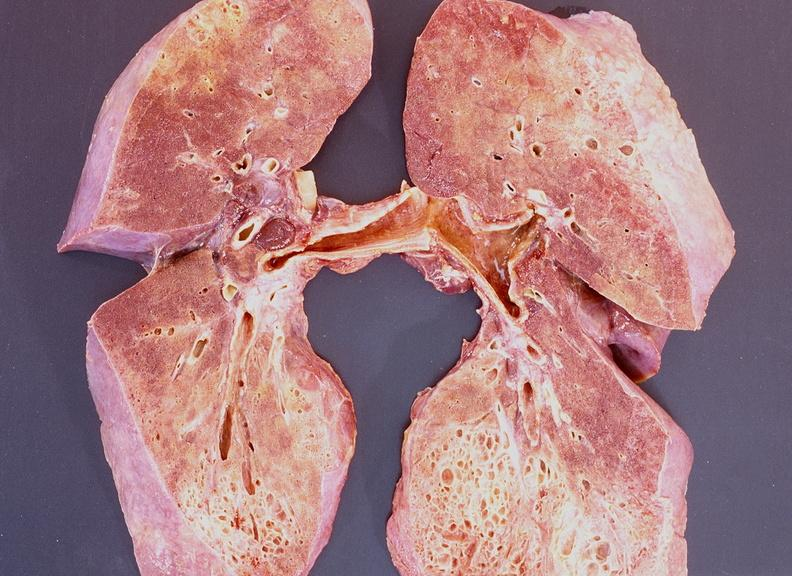what is present?
Answer the question using a single word or phrase. Respiratory 